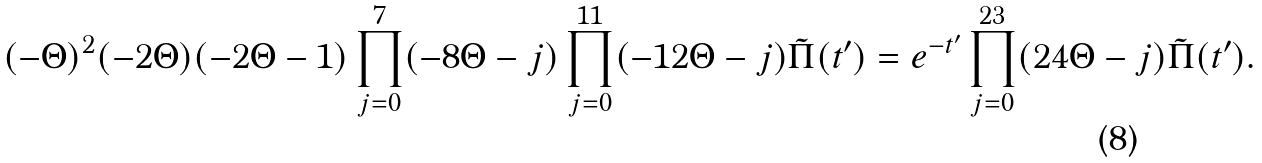Convert formula to latex. <formula><loc_0><loc_0><loc_500><loc_500>( - \Theta ) ^ { 2 } ( - 2 \Theta ) ( - 2 \Theta - 1 ) \prod _ { j = 0 } ^ { 7 } ( - 8 \Theta - j ) \prod _ { j = 0 } ^ { 1 1 } ( - 1 2 \Theta - j ) \tilde { \Pi } ( t ^ { \prime } ) = e ^ { - t ^ { \prime } } \prod _ { j = 0 } ^ { 2 3 } ( 2 4 \Theta - j ) \tilde { \Pi } ( t ^ { \prime } ) .</formula> 